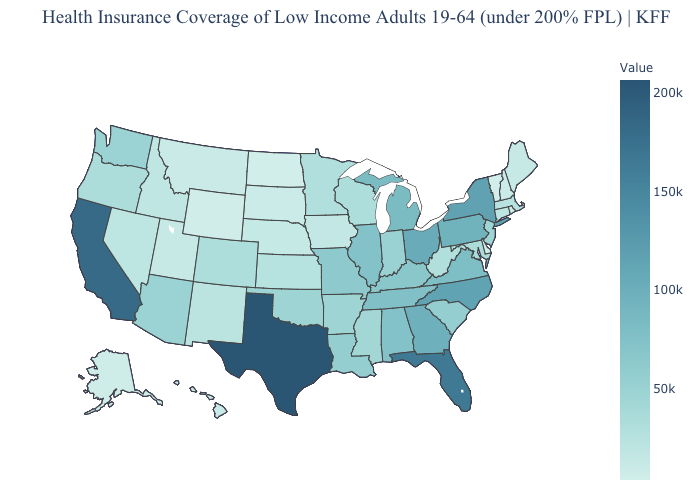Does Arizona have a lower value than Tennessee?
Keep it brief. Yes. Among the states that border California , does Oregon have the highest value?
Short answer required. No. Among the states that border Nevada , which have the lowest value?
Quick response, please. Utah. Does Wyoming have the lowest value in the West?
Quick response, please. Yes. Does Michigan have a higher value than Oregon?
Be succinct. Yes. Which states have the lowest value in the South?
Answer briefly. Delaware. 